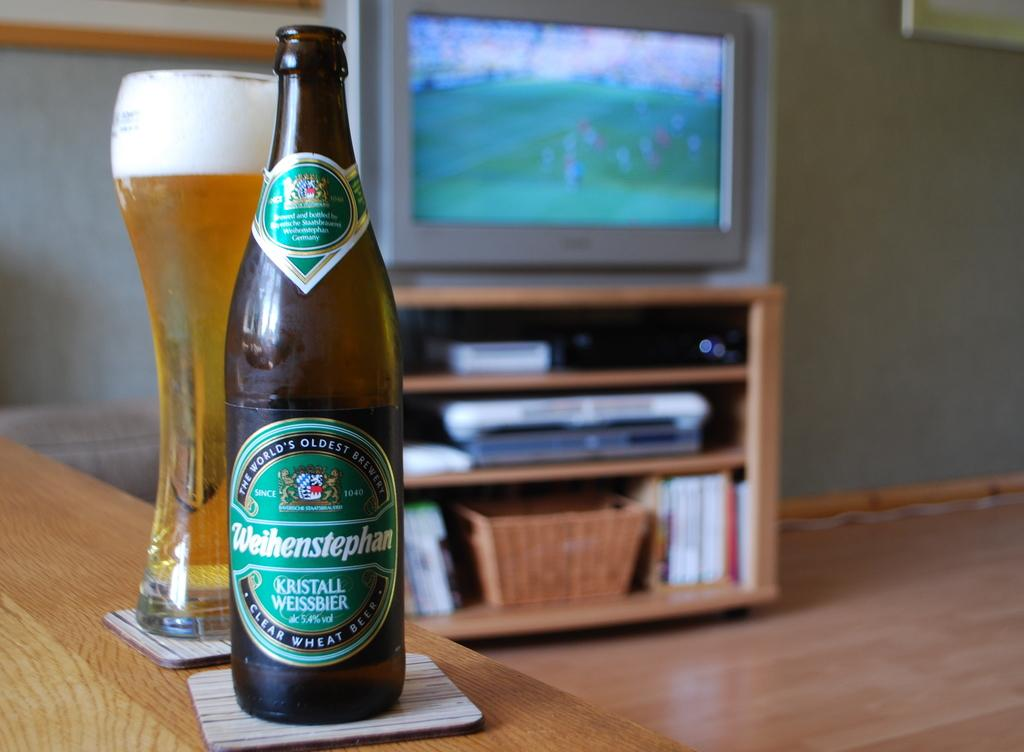Provide a one-sentence caption for the provided image. A bottle of Weihenstephan beer on a coaster. 